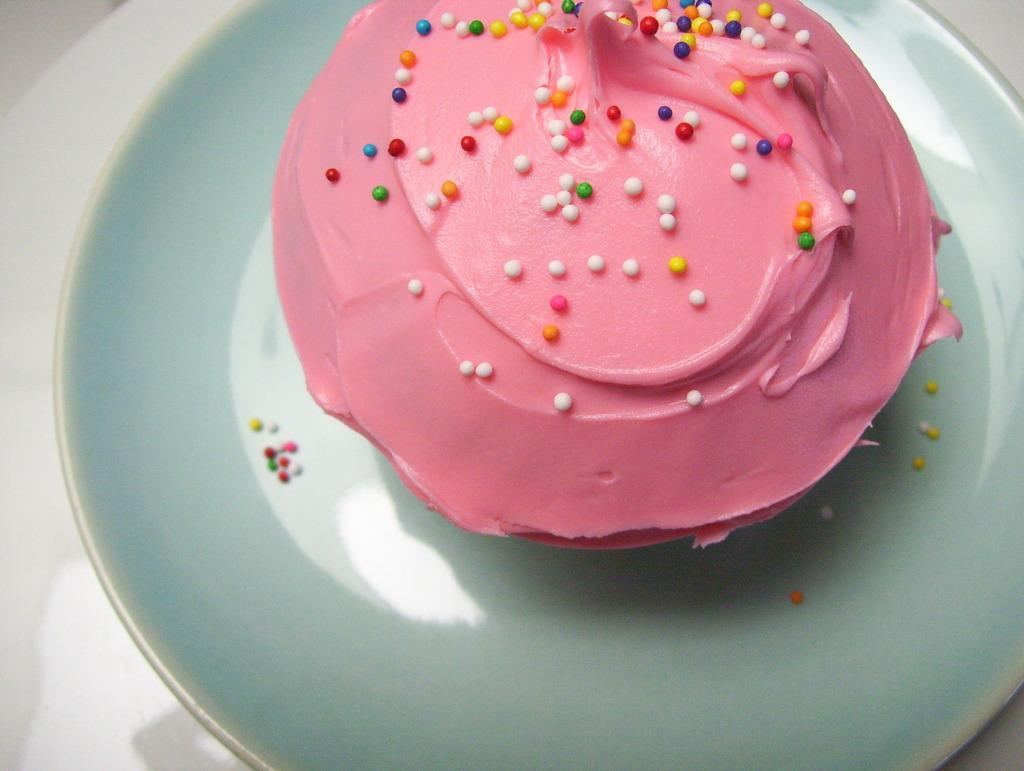Describe this image in one or two sentences. In this image I can see food item on a plate, which is placed on the table or an object. 